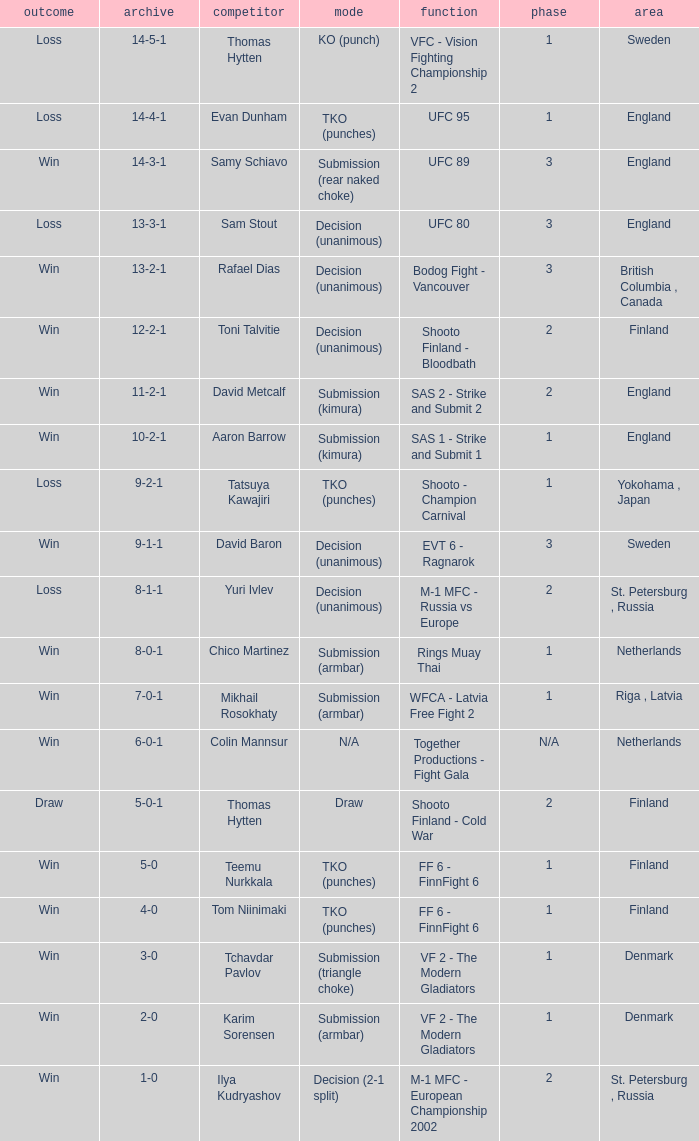What's the location when the record was 6-0-1? Netherlands. 